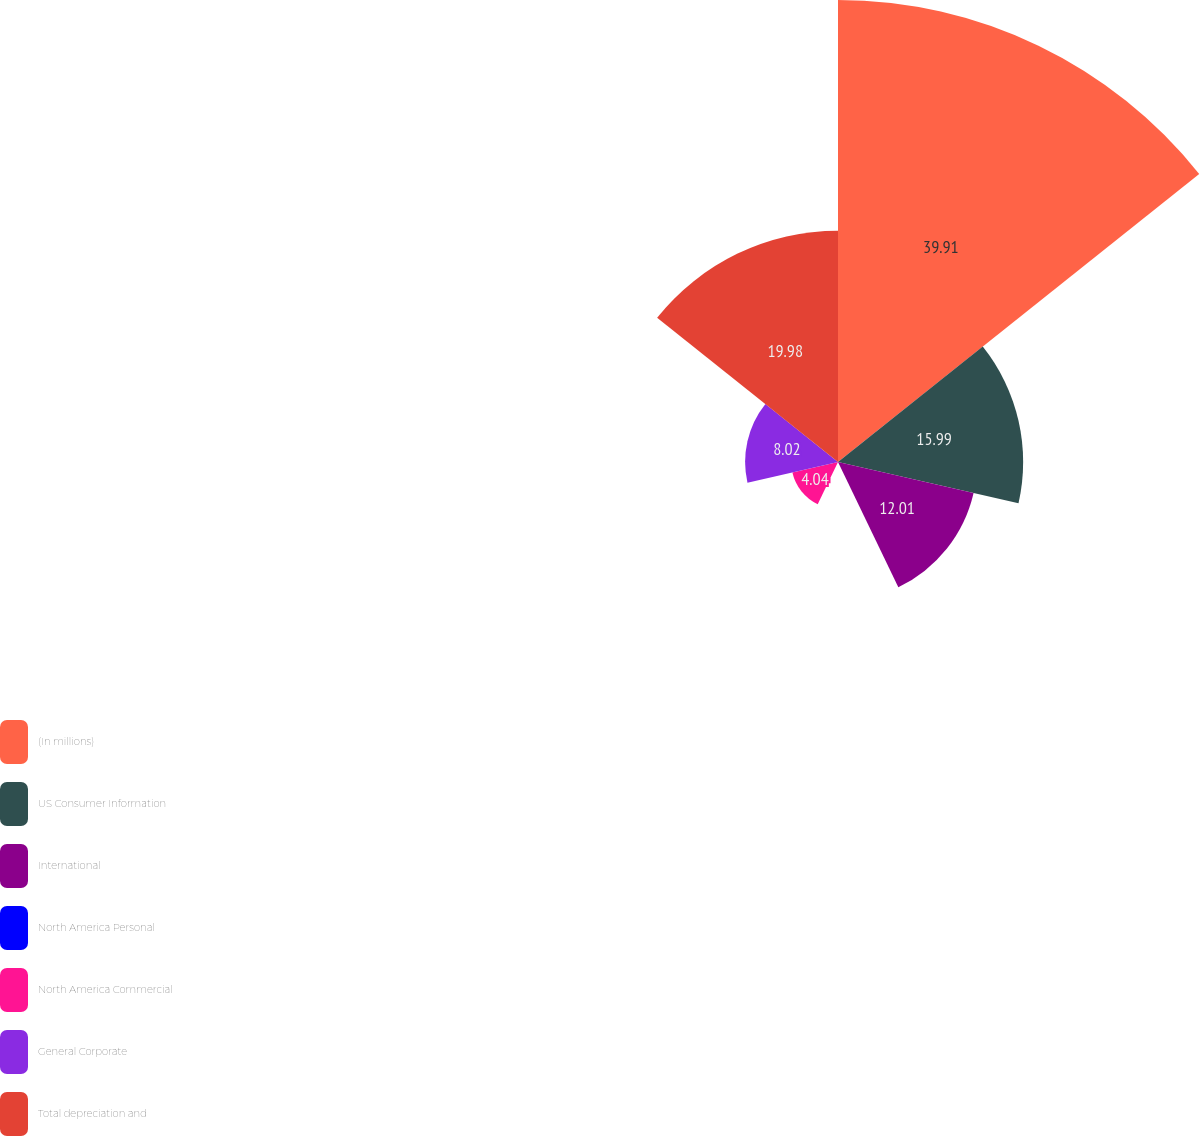<chart> <loc_0><loc_0><loc_500><loc_500><pie_chart><fcel>(In millions)<fcel>US Consumer Information<fcel>International<fcel>North America Personal<fcel>North America Commercial<fcel>General Corporate<fcel>Total depreciation and<nl><fcel>39.9%<fcel>15.99%<fcel>12.01%<fcel>0.05%<fcel>4.04%<fcel>8.02%<fcel>19.98%<nl></chart> 